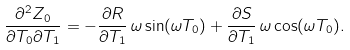<formula> <loc_0><loc_0><loc_500><loc_500>\frac { \partial ^ { 2 } Z _ { 0 } } { \partial T _ { 0 } \partial T _ { 1 } } = - \frac { \partial R } { \partial T _ { 1 } } \, \omega \sin ( \omega T _ { 0 } ) + \frac { \partial S } { \partial T _ { 1 } } \, \omega \cos ( \omega T _ { 0 } ) .</formula> 